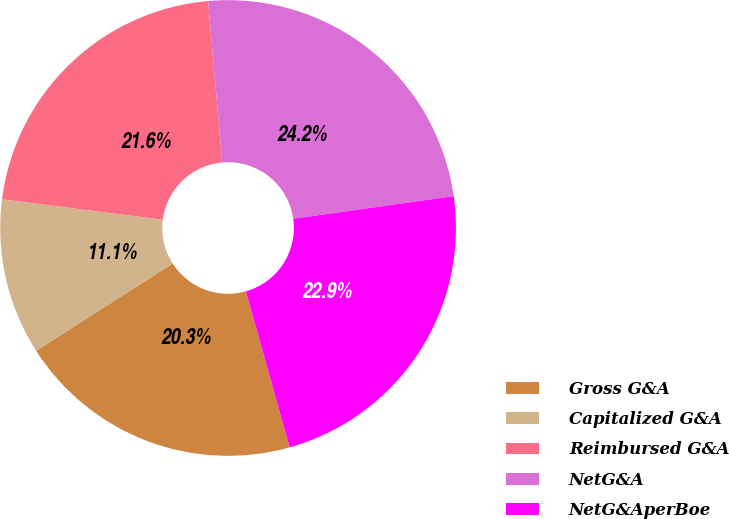<chart> <loc_0><loc_0><loc_500><loc_500><pie_chart><fcel>Gross G&A<fcel>Capitalized G&A<fcel>Reimbursed G&A<fcel>NetG&A<fcel>NetG&AperBoe<nl><fcel>20.3%<fcel>11.07%<fcel>21.59%<fcel>24.17%<fcel>22.88%<nl></chart> 